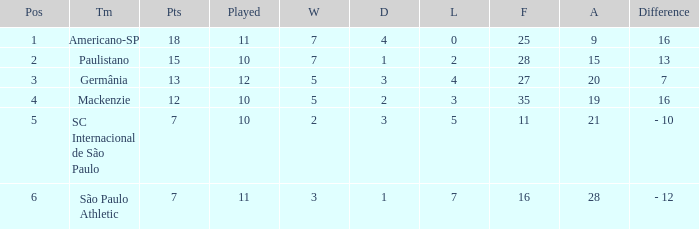Name the most for when difference is 7 27.0. 